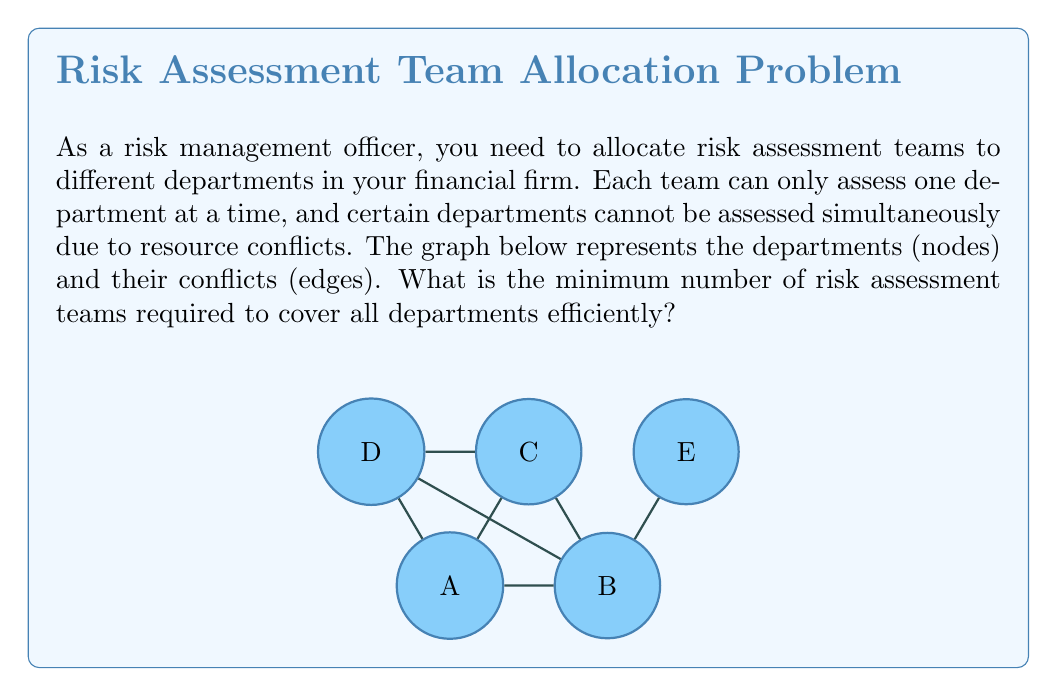Could you help me with this problem? To solve this problem, we can use graph coloring techniques. Each color represents a risk assessment team, and connected nodes (departments with conflicts) must have different colors.

Step 1: Identify the graph structure
The graph is an undirected graph with 5 nodes (A, B, C, D, E) and 7 edges.

Step 2: Apply the greedy coloring algorithm
1. Start with node A, assign color 1.
2. Move to B, it's connected to A, so assign color 2.
3. For C, it's connected to A and B, so assign color 3.
4. For D, it's connected to A, B, and C. Assign color 2 (as it's not connected to the other node with color 2, which is B).
5. For E, it's only connected to B. We can assign color 1.

Step 3: Count the number of colors used
We used 3 colors in total: 1, 2, and 3.

Step 4: Verify the coloring
- No two adjacent nodes have the same color.
- All nodes are colored.

Therefore, the minimum number of risk assessment teams required is equal to the number of colors used, which is 3.
Answer: 3 teams 